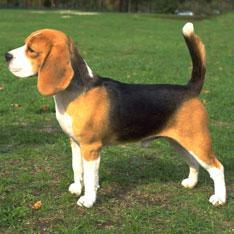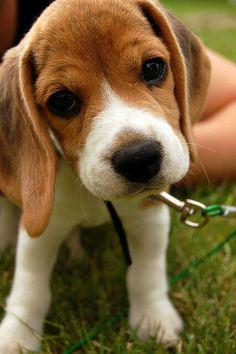The first image is the image on the left, the second image is the image on the right. Given the left and right images, does the statement "An image shows a dog looking up at the camera with a semi-circular shape under its nose." hold true? Answer yes or no. No. The first image is the image on the left, the second image is the image on the right. Given the left and right images, does the statement "beagles are sitting or standing in green grass" hold true? Answer yes or no. Yes. 